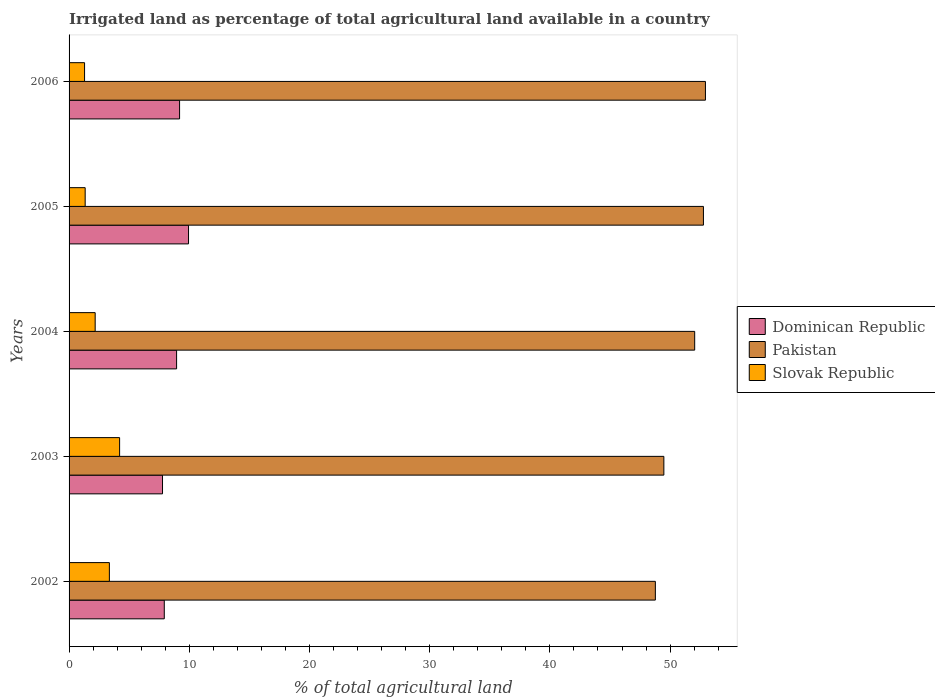How many different coloured bars are there?
Your answer should be very brief. 3. Are the number of bars per tick equal to the number of legend labels?
Your response must be concise. Yes. Are the number of bars on each tick of the Y-axis equal?
Offer a terse response. Yes. How many bars are there on the 4th tick from the top?
Ensure brevity in your answer.  3. What is the label of the 5th group of bars from the top?
Make the answer very short. 2002. In how many cases, is the number of bars for a given year not equal to the number of legend labels?
Offer a terse response. 0. What is the percentage of irrigated land in Pakistan in 2002?
Offer a terse response. 48.77. Across all years, what is the maximum percentage of irrigated land in Dominican Republic?
Provide a short and direct response. 9.94. Across all years, what is the minimum percentage of irrigated land in Slovak Republic?
Offer a terse response. 1.29. In which year was the percentage of irrigated land in Slovak Republic minimum?
Ensure brevity in your answer.  2006. What is the total percentage of irrigated land in Pakistan in the graph?
Offer a terse response. 256.02. What is the difference between the percentage of irrigated land in Dominican Republic in 2003 and that in 2004?
Your answer should be very brief. -1.17. What is the difference between the percentage of irrigated land in Slovak Republic in 2004 and the percentage of irrigated land in Pakistan in 2005?
Offer a terse response. -50.6. What is the average percentage of irrigated land in Dominican Republic per year?
Provide a succinct answer. 8.75. In the year 2004, what is the difference between the percentage of irrigated land in Dominican Republic and percentage of irrigated land in Pakistan?
Offer a terse response. -43.1. What is the ratio of the percentage of irrigated land in Pakistan in 2004 to that in 2006?
Offer a terse response. 0.98. Is the percentage of irrigated land in Dominican Republic in 2004 less than that in 2006?
Your response must be concise. Yes. What is the difference between the highest and the second highest percentage of irrigated land in Dominican Republic?
Provide a short and direct response. 0.74. What is the difference between the highest and the lowest percentage of irrigated land in Dominican Republic?
Give a very brief answer. 2.16. What does the 3rd bar from the top in 2006 represents?
Your answer should be compact. Dominican Republic. Are all the bars in the graph horizontal?
Keep it short and to the point. Yes. What is the difference between two consecutive major ticks on the X-axis?
Give a very brief answer. 10. Where does the legend appear in the graph?
Provide a short and direct response. Center right. How are the legend labels stacked?
Keep it short and to the point. Vertical. What is the title of the graph?
Your response must be concise. Irrigated land as percentage of total agricultural land available in a country. What is the label or title of the X-axis?
Keep it short and to the point. % of total agricultural land. What is the label or title of the Y-axis?
Provide a short and direct response. Years. What is the % of total agricultural land of Dominican Republic in 2002?
Your response must be concise. 7.92. What is the % of total agricultural land in Pakistan in 2002?
Offer a terse response. 48.77. What is the % of total agricultural land of Slovak Republic in 2002?
Offer a terse response. 3.35. What is the % of total agricultural land in Dominican Republic in 2003?
Offer a very short reply. 7.77. What is the % of total agricultural land in Pakistan in 2003?
Provide a short and direct response. 49.48. What is the % of total agricultural land in Slovak Republic in 2003?
Your answer should be compact. 4.2. What is the % of total agricultural land of Dominican Republic in 2004?
Give a very brief answer. 8.94. What is the % of total agricultural land in Pakistan in 2004?
Offer a terse response. 52.05. What is the % of total agricultural land in Slovak Republic in 2004?
Your answer should be very brief. 2.17. What is the % of total agricultural land in Dominican Republic in 2005?
Your response must be concise. 9.94. What is the % of total agricultural land in Pakistan in 2005?
Ensure brevity in your answer.  52.77. What is the % of total agricultural land in Slovak Republic in 2005?
Offer a very short reply. 1.34. What is the % of total agricultural land of Dominican Republic in 2006?
Your answer should be very brief. 9.19. What is the % of total agricultural land in Pakistan in 2006?
Give a very brief answer. 52.94. What is the % of total agricultural land in Slovak Republic in 2006?
Ensure brevity in your answer.  1.29. Across all years, what is the maximum % of total agricultural land of Dominican Republic?
Your answer should be compact. 9.94. Across all years, what is the maximum % of total agricultural land of Pakistan?
Your answer should be very brief. 52.94. Across all years, what is the maximum % of total agricultural land in Slovak Republic?
Ensure brevity in your answer.  4.2. Across all years, what is the minimum % of total agricultural land of Dominican Republic?
Keep it short and to the point. 7.77. Across all years, what is the minimum % of total agricultural land in Pakistan?
Give a very brief answer. 48.77. Across all years, what is the minimum % of total agricultural land in Slovak Republic?
Your response must be concise. 1.29. What is the total % of total agricultural land in Dominican Republic in the graph?
Provide a short and direct response. 43.77. What is the total % of total agricultural land in Pakistan in the graph?
Ensure brevity in your answer.  256.02. What is the total % of total agricultural land in Slovak Republic in the graph?
Give a very brief answer. 12.36. What is the difference between the % of total agricultural land in Dominican Republic in 2002 and that in 2003?
Ensure brevity in your answer.  0.15. What is the difference between the % of total agricultural land in Pakistan in 2002 and that in 2003?
Your answer should be compact. -0.71. What is the difference between the % of total agricultural land of Slovak Republic in 2002 and that in 2003?
Your answer should be very brief. -0.85. What is the difference between the % of total agricultural land in Dominican Republic in 2002 and that in 2004?
Provide a succinct answer. -1.02. What is the difference between the % of total agricultural land of Pakistan in 2002 and that in 2004?
Your response must be concise. -3.27. What is the difference between the % of total agricultural land of Slovak Republic in 2002 and that in 2004?
Keep it short and to the point. 1.18. What is the difference between the % of total agricultural land of Dominican Republic in 2002 and that in 2005?
Your answer should be compact. -2.02. What is the difference between the % of total agricultural land of Pakistan in 2002 and that in 2005?
Ensure brevity in your answer.  -4. What is the difference between the % of total agricultural land in Slovak Republic in 2002 and that in 2005?
Make the answer very short. 2.01. What is the difference between the % of total agricultural land in Dominican Republic in 2002 and that in 2006?
Offer a terse response. -1.27. What is the difference between the % of total agricultural land of Pakistan in 2002 and that in 2006?
Your answer should be compact. -4.17. What is the difference between the % of total agricultural land of Slovak Republic in 2002 and that in 2006?
Your answer should be very brief. 2.06. What is the difference between the % of total agricultural land of Dominican Republic in 2003 and that in 2004?
Offer a very short reply. -1.17. What is the difference between the % of total agricultural land of Pakistan in 2003 and that in 2004?
Offer a terse response. -2.56. What is the difference between the % of total agricultural land of Slovak Republic in 2003 and that in 2004?
Provide a succinct answer. 2.03. What is the difference between the % of total agricultural land in Dominican Republic in 2003 and that in 2005?
Make the answer very short. -2.16. What is the difference between the % of total agricultural land in Pakistan in 2003 and that in 2005?
Provide a succinct answer. -3.29. What is the difference between the % of total agricultural land in Slovak Republic in 2003 and that in 2005?
Your response must be concise. 2.86. What is the difference between the % of total agricultural land in Dominican Republic in 2003 and that in 2006?
Your response must be concise. -1.42. What is the difference between the % of total agricultural land of Pakistan in 2003 and that in 2006?
Provide a short and direct response. -3.46. What is the difference between the % of total agricultural land of Slovak Republic in 2003 and that in 2006?
Give a very brief answer. 2.91. What is the difference between the % of total agricultural land of Dominican Republic in 2004 and that in 2005?
Ensure brevity in your answer.  -0.99. What is the difference between the % of total agricultural land of Pakistan in 2004 and that in 2005?
Provide a succinct answer. -0.73. What is the difference between the % of total agricultural land of Slovak Republic in 2004 and that in 2005?
Ensure brevity in your answer.  0.83. What is the difference between the % of total agricultural land of Dominican Republic in 2004 and that in 2006?
Keep it short and to the point. -0.25. What is the difference between the % of total agricultural land in Pakistan in 2004 and that in 2006?
Your answer should be compact. -0.89. What is the difference between the % of total agricultural land in Slovak Republic in 2004 and that in 2006?
Provide a succinct answer. 0.88. What is the difference between the % of total agricultural land in Dominican Republic in 2005 and that in 2006?
Offer a very short reply. 0.74. What is the difference between the % of total agricultural land of Pakistan in 2005 and that in 2006?
Provide a short and direct response. -0.17. What is the difference between the % of total agricultural land of Slovak Republic in 2005 and that in 2006?
Give a very brief answer. 0.05. What is the difference between the % of total agricultural land in Dominican Republic in 2002 and the % of total agricultural land in Pakistan in 2003?
Keep it short and to the point. -41.56. What is the difference between the % of total agricultural land in Dominican Republic in 2002 and the % of total agricultural land in Slovak Republic in 2003?
Ensure brevity in your answer.  3.72. What is the difference between the % of total agricultural land in Pakistan in 2002 and the % of total agricultural land in Slovak Republic in 2003?
Provide a short and direct response. 44.57. What is the difference between the % of total agricultural land in Dominican Republic in 2002 and the % of total agricultural land in Pakistan in 2004?
Keep it short and to the point. -44.12. What is the difference between the % of total agricultural land in Dominican Republic in 2002 and the % of total agricultural land in Slovak Republic in 2004?
Provide a short and direct response. 5.75. What is the difference between the % of total agricultural land in Pakistan in 2002 and the % of total agricultural land in Slovak Republic in 2004?
Offer a terse response. 46.6. What is the difference between the % of total agricultural land of Dominican Republic in 2002 and the % of total agricultural land of Pakistan in 2005?
Ensure brevity in your answer.  -44.85. What is the difference between the % of total agricultural land of Dominican Republic in 2002 and the % of total agricultural land of Slovak Republic in 2005?
Your response must be concise. 6.58. What is the difference between the % of total agricultural land in Pakistan in 2002 and the % of total agricultural land in Slovak Republic in 2005?
Offer a very short reply. 47.44. What is the difference between the % of total agricultural land in Dominican Republic in 2002 and the % of total agricultural land in Pakistan in 2006?
Keep it short and to the point. -45.02. What is the difference between the % of total agricultural land of Dominican Republic in 2002 and the % of total agricultural land of Slovak Republic in 2006?
Your answer should be very brief. 6.63. What is the difference between the % of total agricultural land in Pakistan in 2002 and the % of total agricultural land in Slovak Republic in 2006?
Offer a terse response. 47.49. What is the difference between the % of total agricultural land in Dominican Republic in 2003 and the % of total agricultural land in Pakistan in 2004?
Offer a terse response. -44.27. What is the difference between the % of total agricultural land of Dominican Republic in 2003 and the % of total agricultural land of Slovak Republic in 2004?
Offer a terse response. 5.6. What is the difference between the % of total agricultural land in Pakistan in 2003 and the % of total agricultural land in Slovak Republic in 2004?
Offer a very short reply. 47.31. What is the difference between the % of total agricultural land in Dominican Republic in 2003 and the % of total agricultural land in Pakistan in 2005?
Provide a short and direct response. -45. What is the difference between the % of total agricultural land in Dominican Republic in 2003 and the % of total agricultural land in Slovak Republic in 2005?
Provide a short and direct response. 6.43. What is the difference between the % of total agricultural land in Pakistan in 2003 and the % of total agricultural land in Slovak Republic in 2005?
Offer a terse response. 48.14. What is the difference between the % of total agricultural land in Dominican Republic in 2003 and the % of total agricultural land in Pakistan in 2006?
Your answer should be very brief. -45.17. What is the difference between the % of total agricultural land of Dominican Republic in 2003 and the % of total agricultural land of Slovak Republic in 2006?
Offer a very short reply. 6.48. What is the difference between the % of total agricultural land in Pakistan in 2003 and the % of total agricultural land in Slovak Republic in 2006?
Offer a very short reply. 48.19. What is the difference between the % of total agricultural land in Dominican Republic in 2004 and the % of total agricultural land in Pakistan in 2005?
Ensure brevity in your answer.  -43.83. What is the difference between the % of total agricultural land in Dominican Republic in 2004 and the % of total agricultural land in Slovak Republic in 2005?
Keep it short and to the point. 7.61. What is the difference between the % of total agricultural land in Pakistan in 2004 and the % of total agricultural land in Slovak Republic in 2005?
Make the answer very short. 50.71. What is the difference between the % of total agricultural land in Dominican Republic in 2004 and the % of total agricultural land in Pakistan in 2006?
Provide a succinct answer. -44. What is the difference between the % of total agricultural land of Dominican Republic in 2004 and the % of total agricultural land of Slovak Republic in 2006?
Provide a succinct answer. 7.66. What is the difference between the % of total agricultural land of Pakistan in 2004 and the % of total agricultural land of Slovak Republic in 2006?
Ensure brevity in your answer.  50.76. What is the difference between the % of total agricultural land of Dominican Republic in 2005 and the % of total agricultural land of Pakistan in 2006?
Make the answer very short. -43. What is the difference between the % of total agricultural land in Dominican Republic in 2005 and the % of total agricultural land in Slovak Republic in 2006?
Give a very brief answer. 8.65. What is the difference between the % of total agricultural land of Pakistan in 2005 and the % of total agricultural land of Slovak Republic in 2006?
Give a very brief answer. 51.48. What is the average % of total agricultural land of Dominican Republic per year?
Offer a terse response. 8.75. What is the average % of total agricultural land in Pakistan per year?
Keep it short and to the point. 51.2. What is the average % of total agricultural land in Slovak Republic per year?
Provide a succinct answer. 2.47. In the year 2002, what is the difference between the % of total agricultural land of Dominican Republic and % of total agricultural land of Pakistan?
Your response must be concise. -40.85. In the year 2002, what is the difference between the % of total agricultural land of Dominican Republic and % of total agricultural land of Slovak Republic?
Your answer should be compact. 4.57. In the year 2002, what is the difference between the % of total agricultural land of Pakistan and % of total agricultural land of Slovak Republic?
Provide a short and direct response. 45.42. In the year 2003, what is the difference between the % of total agricultural land in Dominican Republic and % of total agricultural land in Pakistan?
Your response must be concise. -41.71. In the year 2003, what is the difference between the % of total agricultural land of Dominican Republic and % of total agricultural land of Slovak Republic?
Give a very brief answer. 3.57. In the year 2003, what is the difference between the % of total agricultural land of Pakistan and % of total agricultural land of Slovak Republic?
Your answer should be compact. 45.28. In the year 2004, what is the difference between the % of total agricultural land of Dominican Republic and % of total agricultural land of Pakistan?
Provide a short and direct response. -43.1. In the year 2004, what is the difference between the % of total agricultural land in Dominican Republic and % of total agricultural land in Slovak Republic?
Your response must be concise. 6.77. In the year 2004, what is the difference between the % of total agricultural land in Pakistan and % of total agricultural land in Slovak Republic?
Your answer should be compact. 49.87. In the year 2005, what is the difference between the % of total agricultural land of Dominican Republic and % of total agricultural land of Pakistan?
Offer a very short reply. -42.84. In the year 2005, what is the difference between the % of total agricultural land of Dominican Republic and % of total agricultural land of Slovak Republic?
Offer a terse response. 8.6. In the year 2005, what is the difference between the % of total agricultural land of Pakistan and % of total agricultural land of Slovak Republic?
Give a very brief answer. 51.43. In the year 2006, what is the difference between the % of total agricultural land of Dominican Republic and % of total agricultural land of Pakistan?
Make the answer very short. -43.75. In the year 2006, what is the difference between the % of total agricultural land in Dominican Republic and % of total agricultural land in Slovak Republic?
Ensure brevity in your answer.  7.9. In the year 2006, what is the difference between the % of total agricultural land in Pakistan and % of total agricultural land in Slovak Republic?
Keep it short and to the point. 51.65. What is the ratio of the % of total agricultural land of Dominican Republic in 2002 to that in 2003?
Your answer should be very brief. 1.02. What is the ratio of the % of total agricultural land of Pakistan in 2002 to that in 2003?
Provide a short and direct response. 0.99. What is the ratio of the % of total agricultural land of Slovak Republic in 2002 to that in 2003?
Ensure brevity in your answer.  0.8. What is the ratio of the % of total agricultural land in Dominican Republic in 2002 to that in 2004?
Make the answer very short. 0.89. What is the ratio of the % of total agricultural land in Pakistan in 2002 to that in 2004?
Give a very brief answer. 0.94. What is the ratio of the % of total agricultural land in Slovak Republic in 2002 to that in 2004?
Make the answer very short. 1.54. What is the ratio of the % of total agricultural land in Dominican Republic in 2002 to that in 2005?
Provide a succinct answer. 0.8. What is the ratio of the % of total agricultural land of Pakistan in 2002 to that in 2005?
Offer a very short reply. 0.92. What is the ratio of the % of total agricultural land in Slovak Republic in 2002 to that in 2005?
Provide a short and direct response. 2.5. What is the ratio of the % of total agricultural land in Dominican Republic in 2002 to that in 2006?
Your answer should be compact. 0.86. What is the ratio of the % of total agricultural land of Pakistan in 2002 to that in 2006?
Keep it short and to the point. 0.92. What is the ratio of the % of total agricultural land of Slovak Republic in 2002 to that in 2006?
Ensure brevity in your answer.  2.6. What is the ratio of the % of total agricultural land in Dominican Republic in 2003 to that in 2004?
Offer a very short reply. 0.87. What is the ratio of the % of total agricultural land of Pakistan in 2003 to that in 2004?
Your answer should be compact. 0.95. What is the ratio of the % of total agricultural land in Slovak Republic in 2003 to that in 2004?
Ensure brevity in your answer.  1.94. What is the ratio of the % of total agricultural land in Dominican Republic in 2003 to that in 2005?
Provide a succinct answer. 0.78. What is the ratio of the % of total agricultural land in Pakistan in 2003 to that in 2005?
Make the answer very short. 0.94. What is the ratio of the % of total agricultural land in Slovak Republic in 2003 to that in 2005?
Give a very brief answer. 3.14. What is the ratio of the % of total agricultural land of Dominican Republic in 2003 to that in 2006?
Your answer should be very brief. 0.85. What is the ratio of the % of total agricultural land of Pakistan in 2003 to that in 2006?
Provide a short and direct response. 0.93. What is the ratio of the % of total agricultural land of Slovak Republic in 2003 to that in 2006?
Your answer should be very brief. 3.26. What is the ratio of the % of total agricultural land in Dominican Republic in 2004 to that in 2005?
Your response must be concise. 0.9. What is the ratio of the % of total agricultural land of Pakistan in 2004 to that in 2005?
Make the answer very short. 0.99. What is the ratio of the % of total agricultural land in Slovak Republic in 2004 to that in 2005?
Keep it short and to the point. 1.62. What is the ratio of the % of total agricultural land in Dominican Republic in 2004 to that in 2006?
Keep it short and to the point. 0.97. What is the ratio of the % of total agricultural land of Pakistan in 2004 to that in 2006?
Give a very brief answer. 0.98. What is the ratio of the % of total agricultural land in Slovak Republic in 2004 to that in 2006?
Your response must be concise. 1.68. What is the ratio of the % of total agricultural land in Dominican Republic in 2005 to that in 2006?
Provide a short and direct response. 1.08. What is the ratio of the % of total agricultural land of Pakistan in 2005 to that in 2006?
Give a very brief answer. 1. What is the ratio of the % of total agricultural land in Slovak Republic in 2005 to that in 2006?
Your response must be concise. 1.04. What is the difference between the highest and the second highest % of total agricultural land of Dominican Republic?
Offer a terse response. 0.74. What is the difference between the highest and the second highest % of total agricultural land of Pakistan?
Offer a terse response. 0.17. What is the difference between the highest and the second highest % of total agricultural land of Slovak Republic?
Offer a terse response. 0.85. What is the difference between the highest and the lowest % of total agricultural land in Dominican Republic?
Provide a short and direct response. 2.16. What is the difference between the highest and the lowest % of total agricultural land of Pakistan?
Give a very brief answer. 4.17. What is the difference between the highest and the lowest % of total agricultural land in Slovak Republic?
Provide a succinct answer. 2.91. 